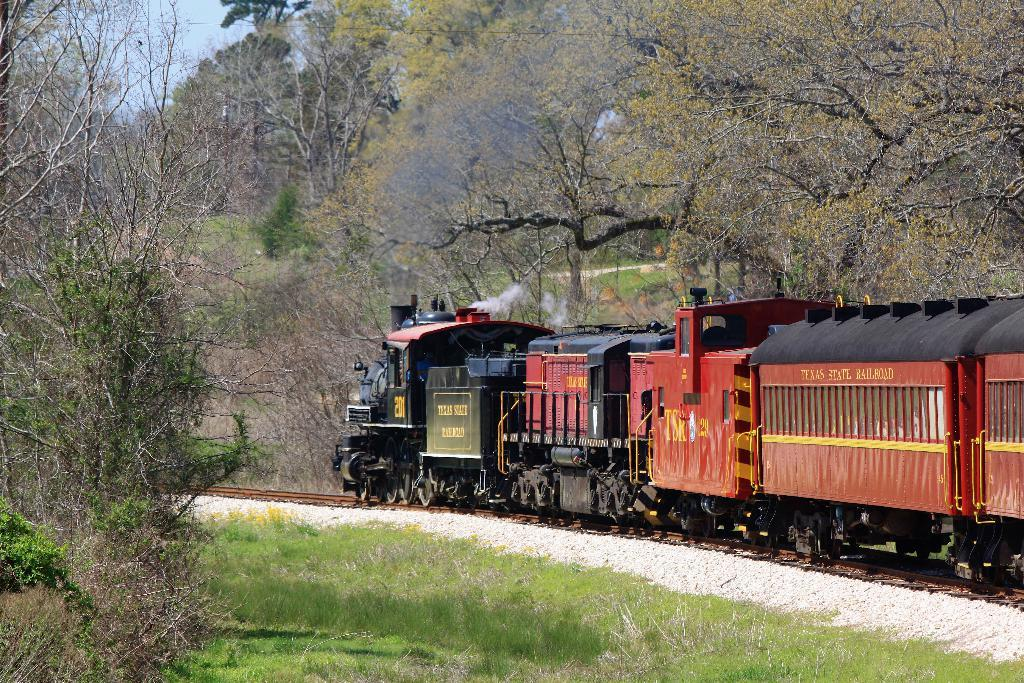What is the main subject of the image? The main subject of the image is a train. Where is the train located in the image? The train is on a track. What type of vegetation can be seen in the image? There is grass and plants visible in the image. What is visible in the background of the image? There are trees and the sky visible in the background of the image. Can you tell me how many cards are being held by the monkey in the image? There is no monkey present in the image, and therefore no cards being held by a monkey. 